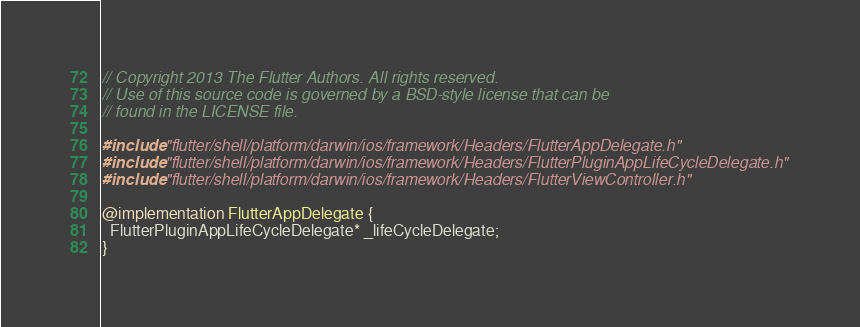<code> <loc_0><loc_0><loc_500><loc_500><_ObjectiveC_>// Copyright 2013 The Flutter Authors. All rights reserved.
// Use of this source code is governed by a BSD-style license that can be
// found in the LICENSE file.

#include "flutter/shell/platform/darwin/ios/framework/Headers/FlutterAppDelegate.h"
#include "flutter/shell/platform/darwin/ios/framework/Headers/FlutterPluginAppLifeCycleDelegate.h"
#include "flutter/shell/platform/darwin/ios/framework/Headers/FlutterViewController.h"

@implementation FlutterAppDelegate {
  FlutterPluginAppLifeCycleDelegate* _lifeCycleDelegate;
}
</code> 